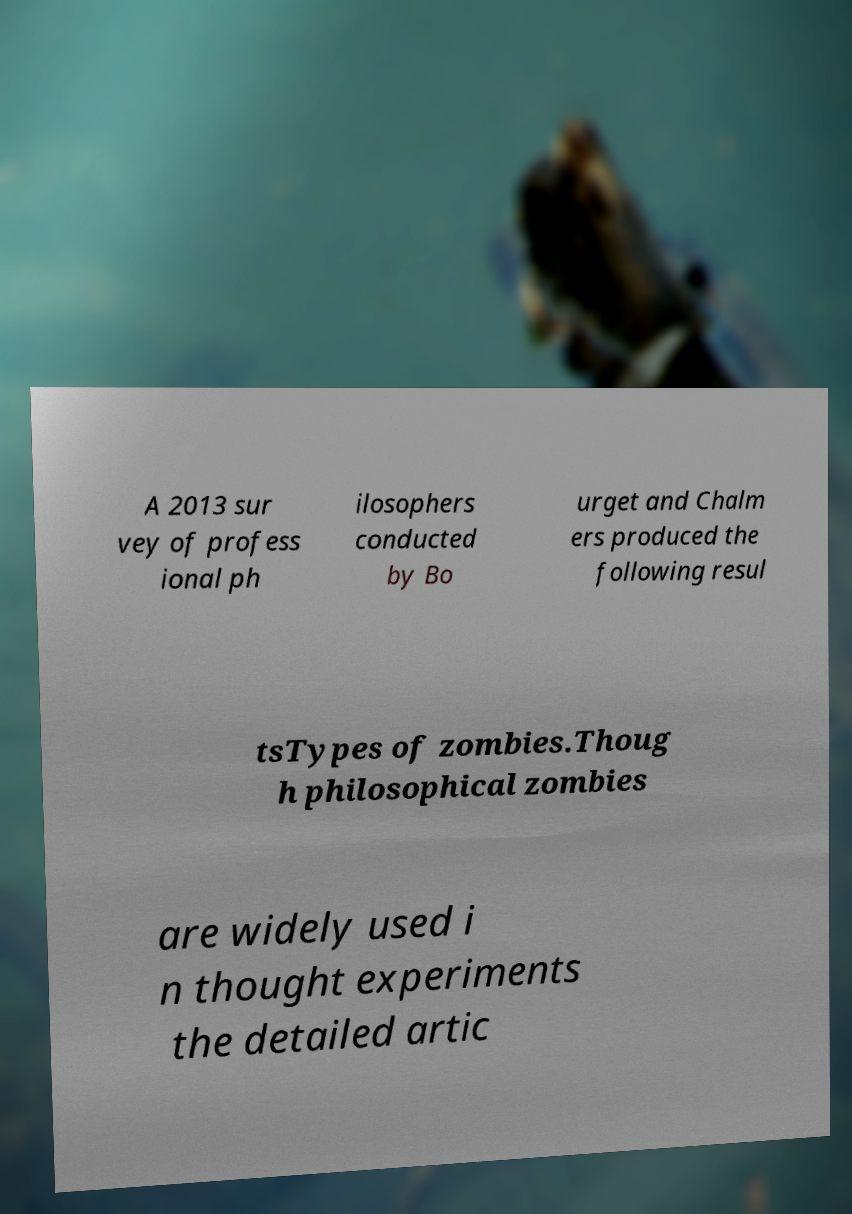Can you read and provide the text displayed in the image?This photo seems to have some interesting text. Can you extract and type it out for me? A 2013 sur vey of profess ional ph ilosophers conducted by Bo urget and Chalm ers produced the following resul tsTypes of zombies.Thoug h philosophical zombies are widely used i n thought experiments the detailed artic 